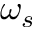Convert formula to latex. <formula><loc_0><loc_0><loc_500><loc_500>\omega _ { s }</formula> 